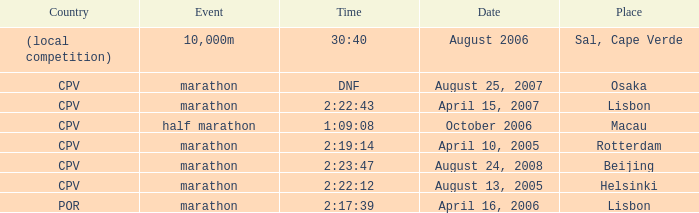What is the nation of the 10,000m competition? (local competition). 